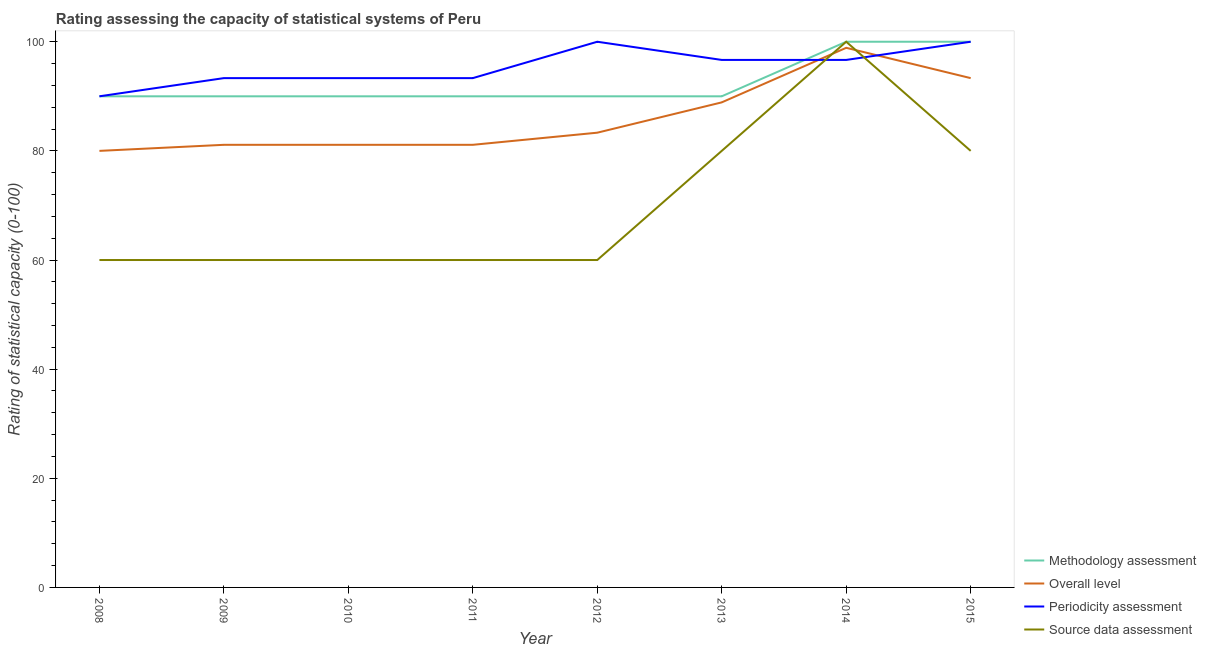Does the line corresponding to source data assessment rating intersect with the line corresponding to overall level rating?
Ensure brevity in your answer.  Yes. What is the methodology assessment rating in 2012?
Provide a succinct answer. 90. Across all years, what is the maximum overall level rating?
Your response must be concise. 98.89. Across all years, what is the minimum methodology assessment rating?
Your answer should be compact. 90. What is the total source data assessment rating in the graph?
Keep it short and to the point. 560. What is the difference between the overall level rating in 2013 and the source data assessment rating in 2008?
Your answer should be very brief. 28.89. What is the average methodology assessment rating per year?
Your answer should be compact. 92.5. In the year 2012, what is the difference between the source data assessment rating and methodology assessment rating?
Provide a succinct answer. -30. What is the ratio of the source data assessment rating in 2010 to that in 2012?
Give a very brief answer. 1. What is the difference between the highest and the second highest periodicity assessment rating?
Your answer should be compact. 0. What is the difference between the highest and the lowest overall level rating?
Keep it short and to the point. 18.89. In how many years, is the periodicity assessment rating greater than the average periodicity assessment rating taken over all years?
Your response must be concise. 4. Is the sum of the methodology assessment rating in 2011 and 2015 greater than the maximum periodicity assessment rating across all years?
Make the answer very short. Yes. Is it the case that in every year, the sum of the methodology assessment rating and periodicity assessment rating is greater than the sum of source data assessment rating and overall level rating?
Make the answer very short. Yes. Is it the case that in every year, the sum of the methodology assessment rating and overall level rating is greater than the periodicity assessment rating?
Provide a short and direct response. Yes. Is the periodicity assessment rating strictly less than the source data assessment rating over the years?
Ensure brevity in your answer.  No. What is the difference between two consecutive major ticks on the Y-axis?
Your answer should be compact. 20. How many legend labels are there?
Offer a very short reply. 4. How are the legend labels stacked?
Offer a very short reply. Vertical. What is the title of the graph?
Your answer should be very brief. Rating assessing the capacity of statistical systems of Peru. Does "Revenue mobilization" appear as one of the legend labels in the graph?
Offer a very short reply. No. What is the label or title of the Y-axis?
Your answer should be compact. Rating of statistical capacity (0-100). What is the Rating of statistical capacity (0-100) in Methodology assessment in 2008?
Ensure brevity in your answer.  90. What is the Rating of statistical capacity (0-100) of Source data assessment in 2008?
Offer a terse response. 60. What is the Rating of statistical capacity (0-100) in Methodology assessment in 2009?
Give a very brief answer. 90. What is the Rating of statistical capacity (0-100) of Overall level in 2009?
Provide a short and direct response. 81.11. What is the Rating of statistical capacity (0-100) of Periodicity assessment in 2009?
Your answer should be very brief. 93.33. What is the Rating of statistical capacity (0-100) of Source data assessment in 2009?
Your answer should be very brief. 60. What is the Rating of statistical capacity (0-100) of Methodology assessment in 2010?
Ensure brevity in your answer.  90. What is the Rating of statistical capacity (0-100) of Overall level in 2010?
Offer a very short reply. 81.11. What is the Rating of statistical capacity (0-100) of Periodicity assessment in 2010?
Your answer should be very brief. 93.33. What is the Rating of statistical capacity (0-100) of Source data assessment in 2010?
Make the answer very short. 60. What is the Rating of statistical capacity (0-100) in Overall level in 2011?
Provide a succinct answer. 81.11. What is the Rating of statistical capacity (0-100) of Periodicity assessment in 2011?
Keep it short and to the point. 93.33. What is the Rating of statistical capacity (0-100) of Source data assessment in 2011?
Your answer should be compact. 60. What is the Rating of statistical capacity (0-100) of Overall level in 2012?
Your answer should be compact. 83.33. What is the Rating of statistical capacity (0-100) of Periodicity assessment in 2012?
Your answer should be compact. 100. What is the Rating of statistical capacity (0-100) of Source data assessment in 2012?
Your response must be concise. 60. What is the Rating of statistical capacity (0-100) of Methodology assessment in 2013?
Keep it short and to the point. 90. What is the Rating of statistical capacity (0-100) in Overall level in 2013?
Your answer should be very brief. 88.89. What is the Rating of statistical capacity (0-100) in Periodicity assessment in 2013?
Ensure brevity in your answer.  96.67. What is the Rating of statistical capacity (0-100) in Source data assessment in 2013?
Provide a short and direct response. 80. What is the Rating of statistical capacity (0-100) of Methodology assessment in 2014?
Keep it short and to the point. 100. What is the Rating of statistical capacity (0-100) of Overall level in 2014?
Keep it short and to the point. 98.89. What is the Rating of statistical capacity (0-100) in Periodicity assessment in 2014?
Ensure brevity in your answer.  96.67. What is the Rating of statistical capacity (0-100) of Source data assessment in 2014?
Ensure brevity in your answer.  100. What is the Rating of statistical capacity (0-100) of Overall level in 2015?
Ensure brevity in your answer.  93.33. What is the Rating of statistical capacity (0-100) of Source data assessment in 2015?
Provide a succinct answer. 80. Across all years, what is the maximum Rating of statistical capacity (0-100) in Methodology assessment?
Make the answer very short. 100. Across all years, what is the maximum Rating of statistical capacity (0-100) in Overall level?
Offer a terse response. 98.89. Across all years, what is the minimum Rating of statistical capacity (0-100) in Methodology assessment?
Your response must be concise. 90. What is the total Rating of statistical capacity (0-100) of Methodology assessment in the graph?
Provide a succinct answer. 740. What is the total Rating of statistical capacity (0-100) in Overall level in the graph?
Your response must be concise. 687.78. What is the total Rating of statistical capacity (0-100) in Periodicity assessment in the graph?
Give a very brief answer. 763.33. What is the total Rating of statistical capacity (0-100) of Source data assessment in the graph?
Ensure brevity in your answer.  560. What is the difference between the Rating of statistical capacity (0-100) in Overall level in 2008 and that in 2009?
Offer a terse response. -1.11. What is the difference between the Rating of statistical capacity (0-100) in Source data assessment in 2008 and that in 2009?
Your answer should be compact. 0. What is the difference between the Rating of statistical capacity (0-100) of Overall level in 2008 and that in 2010?
Your answer should be very brief. -1.11. What is the difference between the Rating of statistical capacity (0-100) in Periodicity assessment in 2008 and that in 2010?
Provide a succinct answer. -3.33. What is the difference between the Rating of statistical capacity (0-100) in Methodology assessment in 2008 and that in 2011?
Make the answer very short. 0. What is the difference between the Rating of statistical capacity (0-100) of Overall level in 2008 and that in 2011?
Your answer should be very brief. -1.11. What is the difference between the Rating of statistical capacity (0-100) of Source data assessment in 2008 and that in 2011?
Give a very brief answer. 0. What is the difference between the Rating of statistical capacity (0-100) of Methodology assessment in 2008 and that in 2012?
Your response must be concise. 0. What is the difference between the Rating of statistical capacity (0-100) of Overall level in 2008 and that in 2012?
Give a very brief answer. -3.33. What is the difference between the Rating of statistical capacity (0-100) in Periodicity assessment in 2008 and that in 2012?
Your response must be concise. -10. What is the difference between the Rating of statistical capacity (0-100) of Source data assessment in 2008 and that in 2012?
Your answer should be compact. 0. What is the difference between the Rating of statistical capacity (0-100) in Methodology assessment in 2008 and that in 2013?
Keep it short and to the point. 0. What is the difference between the Rating of statistical capacity (0-100) of Overall level in 2008 and that in 2013?
Make the answer very short. -8.89. What is the difference between the Rating of statistical capacity (0-100) of Periodicity assessment in 2008 and that in 2013?
Your answer should be compact. -6.67. What is the difference between the Rating of statistical capacity (0-100) of Methodology assessment in 2008 and that in 2014?
Provide a succinct answer. -10. What is the difference between the Rating of statistical capacity (0-100) in Overall level in 2008 and that in 2014?
Offer a very short reply. -18.89. What is the difference between the Rating of statistical capacity (0-100) in Periodicity assessment in 2008 and that in 2014?
Give a very brief answer. -6.67. What is the difference between the Rating of statistical capacity (0-100) in Methodology assessment in 2008 and that in 2015?
Give a very brief answer. -10. What is the difference between the Rating of statistical capacity (0-100) in Overall level in 2008 and that in 2015?
Keep it short and to the point. -13.33. What is the difference between the Rating of statistical capacity (0-100) in Periodicity assessment in 2008 and that in 2015?
Make the answer very short. -10. What is the difference between the Rating of statistical capacity (0-100) in Methodology assessment in 2009 and that in 2010?
Keep it short and to the point. 0. What is the difference between the Rating of statistical capacity (0-100) in Overall level in 2009 and that in 2010?
Provide a short and direct response. 0. What is the difference between the Rating of statistical capacity (0-100) of Source data assessment in 2009 and that in 2010?
Keep it short and to the point. 0. What is the difference between the Rating of statistical capacity (0-100) in Overall level in 2009 and that in 2011?
Your response must be concise. 0. What is the difference between the Rating of statistical capacity (0-100) in Overall level in 2009 and that in 2012?
Make the answer very short. -2.22. What is the difference between the Rating of statistical capacity (0-100) of Periodicity assessment in 2009 and that in 2012?
Offer a very short reply. -6.67. What is the difference between the Rating of statistical capacity (0-100) of Overall level in 2009 and that in 2013?
Offer a very short reply. -7.78. What is the difference between the Rating of statistical capacity (0-100) of Source data assessment in 2009 and that in 2013?
Offer a very short reply. -20. What is the difference between the Rating of statistical capacity (0-100) of Methodology assessment in 2009 and that in 2014?
Your answer should be very brief. -10. What is the difference between the Rating of statistical capacity (0-100) of Overall level in 2009 and that in 2014?
Ensure brevity in your answer.  -17.78. What is the difference between the Rating of statistical capacity (0-100) in Overall level in 2009 and that in 2015?
Give a very brief answer. -12.22. What is the difference between the Rating of statistical capacity (0-100) in Periodicity assessment in 2009 and that in 2015?
Provide a short and direct response. -6.67. What is the difference between the Rating of statistical capacity (0-100) in Overall level in 2010 and that in 2011?
Give a very brief answer. 0. What is the difference between the Rating of statistical capacity (0-100) in Methodology assessment in 2010 and that in 2012?
Provide a short and direct response. 0. What is the difference between the Rating of statistical capacity (0-100) of Overall level in 2010 and that in 2012?
Make the answer very short. -2.22. What is the difference between the Rating of statistical capacity (0-100) of Periodicity assessment in 2010 and that in 2012?
Your answer should be very brief. -6.67. What is the difference between the Rating of statistical capacity (0-100) in Source data assessment in 2010 and that in 2012?
Your answer should be compact. 0. What is the difference between the Rating of statistical capacity (0-100) in Overall level in 2010 and that in 2013?
Offer a terse response. -7.78. What is the difference between the Rating of statistical capacity (0-100) in Overall level in 2010 and that in 2014?
Provide a short and direct response. -17.78. What is the difference between the Rating of statistical capacity (0-100) of Periodicity assessment in 2010 and that in 2014?
Your response must be concise. -3.33. What is the difference between the Rating of statistical capacity (0-100) in Methodology assessment in 2010 and that in 2015?
Your response must be concise. -10. What is the difference between the Rating of statistical capacity (0-100) in Overall level in 2010 and that in 2015?
Your answer should be compact. -12.22. What is the difference between the Rating of statistical capacity (0-100) in Periodicity assessment in 2010 and that in 2015?
Your answer should be very brief. -6.67. What is the difference between the Rating of statistical capacity (0-100) in Overall level in 2011 and that in 2012?
Ensure brevity in your answer.  -2.22. What is the difference between the Rating of statistical capacity (0-100) in Periodicity assessment in 2011 and that in 2012?
Your answer should be compact. -6.67. What is the difference between the Rating of statistical capacity (0-100) of Methodology assessment in 2011 and that in 2013?
Offer a terse response. 0. What is the difference between the Rating of statistical capacity (0-100) in Overall level in 2011 and that in 2013?
Your response must be concise. -7.78. What is the difference between the Rating of statistical capacity (0-100) of Source data assessment in 2011 and that in 2013?
Offer a terse response. -20. What is the difference between the Rating of statistical capacity (0-100) of Overall level in 2011 and that in 2014?
Make the answer very short. -17.78. What is the difference between the Rating of statistical capacity (0-100) in Periodicity assessment in 2011 and that in 2014?
Ensure brevity in your answer.  -3.33. What is the difference between the Rating of statistical capacity (0-100) in Overall level in 2011 and that in 2015?
Keep it short and to the point. -12.22. What is the difference between the Rating of statistical capacity (0-100) of Periodicity assessment in 2011 and that in 2015?
Make the answer very short. -6.67. What is the difference between the Rating of statistical capacity (0-100) of Overall level in 2012 and that in 2013?
Keep it short and to the point. -5.56. What is the difference between the Rating of statistical capacity (0-100) in Methodology assessment in 2012 and that in 2014?
Provide a short and direct response. -10. What is the difference between the Rating of statistical capacity (0-100) of Overall level in 2012 and that in 2014?
Your response must be concise. -15.56. What is the difference between the Rating of statistical capacity (0-100) in Periodicity assessment in 2012 and that in 2014?
Offer a terse response. 3.33. What is the difference between the Rating of statistical capacity (0-100) of Source data assessment in 2012 and that in 2014?
Give a very brief answer. -40. What is the difference between the Rating of statistical capacity (0-100) in Methodology assessment in 2012 and that in 2015?
Your answer should be compact. -10. What is the difference between the Rating of statistical capacity (0-100) in Source data assessment in 2012 and that in 2015?
Provide a succinct answer. -20. What is the difference between the Rating of statistical capacity (0-100) in Overall level in 2013 and that in 2014?
Keep it short and to the point. -10. What is the difference between the Rating of statistical capacity (0-100) in Source data assessment in 2013 and that in 2014?
Provide a short and direct response. -20. What is the difference between the Rating of statistical capacity (0-100) in Overall level in 2013 and that in 2015?
Give a very brief answer. -4.44. What is the difference between the Rating of statistical capacity (0-100) in Periodicity assessment in 2013 and that in 2015?
Offer a terse response. -3.33. What is the difference between the Rating of statistical capacity (0-100) of Overall level in 2014 and that in 2015?
Your answer should be very brief. 5.56. What is the difference between the Rating of statistical capacity (0-100) of Source data assessment in 2014 and that in 2015?
Your answer should be very brief. 20. What is the difference between the Rating of statistical capacity (0-100) in Methodology assessment in 2008 and the Rating of statistical capacity (0-100) in Overall level in 2009?
Your answer should be very brief. 8.89. What is the difference between the Rating of statistical capacity (0-100) in Methodology assessment in 2008 and the Rating of statistical capacity (0-100) in Periodicity assessment in 2009?
Ensure brevity in your answer.  -3.33. What is the difference between the Rating of statistical capacity (0-100) of Overall level in 2008 and the Rating of statistical capacity (0-100) of Periodicity assessment in 2009?
Ensure brevity in your answer.  -13.33. What is the difference between the Rating of statistical capacity (0-100) in Methodology assessment in 2008 and the Rating of statistical capacity (0-100) in Overall level in 2010?
Offer a very short reply. 8.89. What is the difference between the Rating of statistical capacity (0-100) of Methodology assessment in 2008 and the Rating of statistical capacity (0-100) of Periodicity assessment in 2010?
Make the answer very short. -3.33. What is the difference between the Rating of statistical capacity (0-100) of Methodology assessment in 2008 and the Rating of statistical capacity (0-100) of Source data assessment in 2010?
Offer a terse response. 30. What is the difference between the Rating of statistical capacity (0-100) in Overall level in 2008 and the Rating of statistical capacity (0-100) in Periodicity assessment in 2010?
Your answer should be compact. -13.33. What is the difference between the Rating of statistical capacity (0-100) of Methodology assessment in 2008 and the Rating of statistical capacity (0-100) of Overall level in 2011?
Offer a terse response. 8.89. What is the difference between the Rating of statistical capacity (0-100) of Overall level in 2008 and the Rating of statistical capacity (0-100) of Periodicity assessment in 2011?
Keep it short and to the point. -13.33. What is the difference between the Rating of statistical capacity (0-100) of Overall level in 2008 and the Rating of statistical capacity (0-100) of Source data assessment in 2011?
Provide a succinct answer. 20. What is the difference between the Rating of statistical capacity (0-100) of Periodicity assessment in 2008 and the Rating of statistical capacity (0-100) of Source data assessment in 2011?
Ensure brevity in your answer.  30. What is the difference between the Rating of statistical capacity (0-100) in Methodology assessment in 2008 and the Rating of statistical capacity (0-100) in Overall level in 2012?
Keep it short and to the point. 6.67. What is the difference between the Rating of statistical capacity (0-100) of Methodology assessment in 2008 and the Rating of statistical capacity (0-100) of Periodicity assessment in 2012?
Offer a terse response. -10. What is the difference between the Rating of statistical capacity (0-100) of Methodology assessment in 2008 and the Rating of statistical capacity (0-100) of Source data assessment in 2012?
Make the answer very short. 30. What is the difference between the Rating of statistical capacity (0-100) of Overall level in 2008 and the Rating of statistical capacity (0-100) of Source data assessment in 2012?
Provide a short and direct response. 20. What is the difference between the Rating of statistical capacity (0-100) in Methodology assessment in 2008 and the Rating of statistical capacity (0-100) in Overall level in 2013?
Offer a very short reply. 1.11. What is the difference between the Rating of statistical capacity (0-100) in Methodology assessment in 2008 and the Rating of statistical capacity (0-100) in Periodicity assessment in 2013?
Provide a short and direct response. -6.67. What is the difference between the Rating of statistical capacity (0-100) of Overall level in 2008 and the Rating of statistical capacity (0-100) of Periodicity assessment in 2013?
Make the answer very short. -16.67. What is the difference between the Rating of statistical capacity (0-100) of Methodology assessment in 2008 and the Rating of statistical capacity (0-100) of Overall level in 2014?
Your answer should be very brief. -8.89. What is the difference between the Rating of statistical capacity (0-100) of Methodology assessment in 2008 and the Rating of statistical capacity (0-100) of Periodicity assessment in 2014?
Your response must be concise. -6.67. What is the difference between the Rating of statistical capacity (0-100) in Methodology assessment in 2008 and the Rating of statistical capacity (0-100) in Source data assessment in 2014?
Give a very brief answer. -10. What is the difference between the Rating of statistical capacity (0-100) of Overall level in 2008 and the Rating of statistical capacity (0-100) of Periodicity assessment in 2014?
Make the answer very short. -16.67. What is the difference between the Rating of statistical capacity (0-100) in Overall level in 2008 and the Rating of statistical capacity (0-100) in Source data assessment in 2014?
Offer a terse response. -20. What is the difference between the Rating of statistical capacity (0-100) in Methodology assessment in 2008 and the Rating of statistical capacity (0-100) in Overall level in 2015?
Provide a succinct answer. -3.33. What is the difference between the Rating of statistical capacity (0-100) in Methodology assessment in 2008 and the Rating of statistical capacity (0-100) in Periodicity assessment in 2015?
Make the answer very short. -10. What is the difference between the Rating of statistical capacity (0-100) in Overall level in 2008 and the Rating of statistical capacity (0-100) in Periodicity assessment in 2015?
Your response must be concise. -20. What is the difference between the Rating of statistical capacity (0-100) of Overall level in 2008 and the Rating of statistical capacity (0-100) of Source data assessment in 2015?
Offer a terse response. 0. What is the difference between the Rating of statistical capacity (0-100) of Methodology assessment in 2009 and the Rating of statistical capacity (0-100) of Overall level in 2010?
Offer a very short reply. 8.89. What is the difference between the Rating of statistical capacity (0-100) of Methodology assessment in 2009 and the Rating of statistical capacity (0-100) of Periodicity assessment in 2010?
Your response must be concise. -3.33. What is the difference between the Rating of statistical capacity (0-100) in Overall level in 2009 and the Rating of statistical capacity (0-100) in Periodicity assessment in 2010?
Give a very brief answer. -12.22. What is the difference between the Rating of statistical capacity (0-100) of Overall level in 2009 and the Rating of statistical capacity (0-100) of Source data assessment in 2010?
Your answer should be compact. 21.11. What is the difference between the Rating of statistical capacity (0-100) in Periodicity assessment in 2009 and the Rating of statistical capacity (0-100) in Source data assessment in 2010?
Ensure brevity in your answer.  33.33. What is the difference between the Rating of statistical capacity (0-100) of Methodology assessment in 2009 and the Rating of statistical capacity (0-100) of Overall level in 2011?
Your response must be concise. 8.89. What is the difference between the Rating of statistical capacity (0-100) in Methodology assessment in 2009 and the Rating of statistical capacity (0-100) in Periodicity assessment in 2011?
Your response must be concise. -3.33. What is the difference between the Rating of statistical capacity (0-100) in Overall level in 2009 and the Rating of statistical capacity (0-100) in Periodicity assessment in 2011?
Make the answer very short. -12.22. What is the difference between the Rating of statistical capacity (0-100) in Overall level in 2009 and the Rating of statistical capacity (0-100) in Source data assessment in 2011?
Offer a terse response. 21.11. What is the difference between the Rating of statistical capacity (0-100) in Periodicity assessment in 2009 and the Rating of statistical capacity (0-100) in Source data assessment in 2011?
Keep it short and to the point. 33.33. What is the difference between the Rating of statistical capacity (0-100) of Methodology assessment in 2009 and the Rating of statistical capacity (0-100) of Periodicity assessment in 2012?
Your answer should be very brief. -10. What is the difference between the Rating of statistical capacity (0-100) in Overall level in 2009 and the Rating of statistical capacity (0-100) in Periodicity assessment in 2012?
Your response must be concise. -18.89. What is the difference between the Rating of statistical capacity (0-100) of Overall level in 2009 and the Rating of statistical capacity (0-100) of Source data assessment in 2012?
Your response must be concise. 21.11. What is the difference between the Rating of statistical capacity (0-100) of Periodicity assessment in 2009 and the Rating of statistical capacity (0-100) of Source data assessment in 2012?
Give a very brief answer. 33.33. What is the difference between the Rating of statistical capacity (0-100) in Methodology assessment in 2009 and the Rating of statistical capacity (0-100) in Overall level in 2013?
Give a very brief answer. 1.11. What is the difference between the Rating of statistical capacity (0-100) of Methodology assessment in 2009 and the Rating of statistical capacity (0-100) of Periodicity assessment in 2013?
Provide a short and direct response. -6.67. What is the difference between the Rating of statistical capacity (0-100) in Methodology assessment in 2009 and the Rating of statistical capacity (0-100) in Source data assessment in 2013?
Make the answer very short. 10. What is the difference between the Rating of statistical capacity (0-100) of Overall level in 2009 and the Rating of statistical capacity (0-100) of Periodicity assessment in 2013?
Your response must be concise. -15.56. What is the difference between the Rating of statistical capacity (0-100) in Periodicity assessment in 2009 and the Rating of statistical capacity (0-100) in Source data assessment in 2013?
Give a very brief answer. 13.33. What is the difference between the Rating of statistical capacity (0-100) of Methodology assessment in 2009 and the Rating of statistical capacity (0-100) of Overall level in 2014?
Give a very brief answer. -8.89. What is the difference between the Rating of statistical capacity (0-100) in Methodology assessment in 2009 and the Rating of statistical capacity (0-100) in Periodicity assessment in 2014?
Offer a very short reply. -6.67. What is the difference between the Rating of statistical capacity (0-100) in Methodology assessment in 2009 and the Rating of statistical capacity (0-100) in Source data assessment in 2014?
Provide a succinct answer. -10. What is the difference between the Rating of statistical capacity (0-100) in Overall level in 2009 and the Rating of statistical capacity (0-100) in Periodicity assessment in 2014?
Your answer should be compact. -15.56. What is the difference between the Rating of statistical capacity (0-100) in Overall level in 2009 and the Rating of statistical capacity (0-100) in Source data assessment in 2014?
Provide a succinct answer. -18.89. What is the difference between the Rating of statistical capacity (0-100) of Periodicity assessment in 2009 and the Rating of statistical capacity (0-100) of Source data assessment in 2014?
Provide a succinct answer. -6.67. What is the difference between the Rating of statistical capacity (0-100) in Overall level in 2009 and the Rating of statistical capacity (0-100) in Periodicity assessment in 2015?
Your answer should be compact. -18.89. What is the difference between the Rating of statistical capacity (0-100) of Periodicity assessment in 2009 and the Rating of statistical capacity (0-100) of Source data assessment in 2015?
Your answer should be compact. 13.33. What is the difference between the Rating of statistical capacity (0-100) in Methodology assessment in 2010 and the Rating of statistical capacity (0-100) in Overall level in 2011?
Offer a terse response. 8.89. What is the difference between the Rating of statistical capacity (0-100) of Overall level in 2010 and the Rating of statistical capacity (0-100) of Periodicity assessment in 2011?
Keep it short and to the point. -12.22. What is the difference between the Rating of statistical capacity (0-100) of Overall level in 2010 and the Rating of statistical capacity (0-100) of Source data assessment in 2011?
Your answer should be very brief. 21.11. What is the difference between the Rating of statistical capacity (0-100) of Periodicity assessment in 2010 and the Rating of statistical capacity (0-100) of Source data assessment in 2011?
Ensure brevity in your answer.  33.33. What is the difference between the Rating of statistical capacity (0-100) in Methodology assessment in 2010 and the Rating of statistical capacity (0-100) in Overall level in 2012?
Keep it short and to the point. 6.67. What is the difference between the Rating of statistical capacity (0-100) in Methodology assessment in 2010 and the Rating of statistical capacity (0-100) in Periodicity assessment in 2012?
Provide a succinct answer. -10. What is the difference between the Rating of statistical capacity (0-100) in Methodology assessment in 2010 and the Rating of statistical capacity (0-100) in Source data assessment in 2012?
Your answer should be very brief. 30. What is the difference between the Rating of statistical capacity (0-100) of Overall level in 2010 and the Rating of statistical capacity (0-100) of Periodicity assessment in 2012?
Keep it short and to the point. -18.89. What is the difference between the Rating of statistical capacity (0-100) of Overall level in 2010 and the Rating of statistical capacity (0-100) of Source data assessment in 2012?
Your answer should be compact. 21.11. What is the difference between the Rating of statistical capacity (0-100) in Periodicity assessment in 2010 and the Rating of statistical capacity (0-100) in Source data assessment in 2012?
Keep it short and to the point. 33.33. What is the difference between the Rating of statistical capacity (0-100) in Methodology assessment in 2010 and the Rating of statistical capacity (0-100) in Overall level in 2013?
Your answer should be very brief. 1.11. What is the difference between the Rating of statistical capacity (0-100) in Methodology assessment in 2010 and the Rating of statistical capacity (0-100) in Periodicity assessment in 2013?
Keep it short and to the point. -6.67. What is the difference between the Rating of statistical capacity (0-100) in Overall level in 2010 and the Rating of statistical capacity (0-100) in Periodicity assessment in 2013?
Provide a short and direct response. -15.56. What is the difference between the Rating of statistical capacity (0-100) of Periodicity assessment in 2010 and the Rating of statistical capacity (0-100) of Source data assessment in 2013?
Provide a short and direct response. 13.33. What is the difference between the Rating of statistical capacity (0-100) in Methodology assessment in 2010 and the Rating of statistical capacity (0-100) in Overall level in 2014?
Offer a terse response. -8.89. What is the difference between the Rating of statistical capacity (0-100) of Methodology assessment in 2010 and the Rating of statistical capacity (0-100) of Periodicity assessment in 2014?
Provide a short and direct response. -6.67. What is the difference between the Rating of statistical capacity (0-100) of Methodology assessment in 2010 and the Rating of statistical capacity (0-100) of Source data assessment in 2014?
Give a very brief answer. -10. What is the difference between the Rating of statistical capacity (0-100) in Overall level in 2010 and the Rating of statistical capacity (0-100) in Periodicity assessment in 2014?
Give a very brief answer. -15.56. What is the difference between the Rating of statistical capacity (0-100) of Overall level in 2010 and the Rating of statistical capacity (0-100) of Source data assessment in 2014?
Ensure brevity in your answer.  -18.89. What is the difference between the Rating of statistical capacity (0-100) of Periodicity assessment in 2010 and the Rating of statistical capacity (0-100) of Source data assessment in 2014?
Ensure brevity in your answer.  -6.67. What is the difference between the Rating of statistical capacity (0-100) in Methodology assessment in 2010 and the Rating of statistical capacity (0-100) in Overall level in 2015?
Your response must be concise. -3.33. What is the difference between the Rating of statistical capacity (0-100) of Methodology assessment in 2010 and the Rating of statistical capacity (0-100) of Periodicity assessment in 2015?
Your answer should be very brief. -10. What is the difference between the Rating of statistical capacity (0-100) of Overall level in 2010 and the Rating of statistical capacity (0-100) of Periodicity assessment in 2015?
Ensure brevity in your answer.  -18.89. What is the difference between the Rating of statistical capacity (0-100) of Periodicity assessment in 2010 and the Rating of statistical capacity (0-100) of Source data assessment in 2015?
Your response must be concise. 13.33. What is the difference between the Rating of statistical capacity (0-100) in Methodology assessment in 2011 and the Rating of statistical capacity (0-100) in Overall level in 2012?
Offer a terse response. 6.67. What is the difference between the Rating of statistical capacity (0-100) in Methodology assessment in 2011 and the Rating of statistical capacity (0-100) in Source data assessment in 2012?
Keep it short and to the point. 30. What is the difference between the Rating of statistical capacity (0-100) of Overall level in 2011 and the Rating of statistical capacity (0-100) of Periodicity assessment in 2012?
Make the answer very short. -18.89. What is the difference between the Rating of statistical capacity (0-100) in Overall level in 2011 and the Rating of statistical capacity (0-100) in Source data assessment in 2012?
Offer a very short reply. 21.11. What is the difference between the Rating of statistical capacity (0-100) of Periodicity assessment in 2011 and the Rating of statistical capacity (0-100) of Source data assessment in 2012?
Keep it short and to the point. 33.33. What is the difference between the Rating of statistical capacity (0-100) of Methodology assessment in 2011 and the Rating of statistical capacity (0-100) of Overall level in 2013?
Keep it short and to the point. 1.11. What is the difference between the Rating of statistical capacity (0-100) of Methodology assessment in 2011 and the Rating of statistical capacity (0-100) of Periodicity assessment in 2013?
Your response must be concise. -6.67. What is the difference between the Rating of statistical capacity (0-100) in Methodology assessment in 2011 and the Rating of statistical capacity (0-100) in Source data assessment in 2013?
Your response must be concise. 10. What is the difference between the Rating of statistical capacity (0-100) of Overall level in 2011 and the Rating of statistical capacity (0-100) of Periodicity assessment in 2013?
Keep it short and to the point. -15.56. What is the difference between the Rating of statistical capacity (0-100) of Overall level in 2011 and the Rating of statistical capacity (0-100) of Source data assessment in 2013?
Your answer should be compact. 1.11. What is the difference between the Rating of statistical capacity (0-100) of Periodicity assessment in 2011 and the Rating of statistical capacity (0-100) of Source data assessment in 2013?
Your response must be concise. 13.33. What is the difference between the Rating of statistical capacity (0-100) of Methodology assessment in 2011 and the Rating of statistical capacity (0-100) of Overall level in 2014?
Keep it short and to the point. -8.89. What is the difference between the Rating of statistical capacity (0-100) in Methodology assessment in 2011 and the Rating of statistical capacity (0-100) in Periodicity assessment in 2014?
Provide a succinct answer. -6.67. What is the difference between the Rating of statistical capacity (0-100) in Overall level in 2011 and the Rating of statistical capacity (0-100) in Periodicity assessment in 2014?
Ensure brevity in your answer.  -15.56. What is the difference between the Rating of statistical capacity (0-100) in Overall level in 2011 and the Rating of statistical capacity (0-100) in Source data assessment in 2014?
Your answer should be compact. -18.89. What is the difference between the Rating of statistical capacity (0-100) of Periodicity assessment in 2011 and the Rating of statistical capacity (0-100) of Source data assessment in 2014?
Your answer should be very brief. -6.67. What is the difference between the Rating of statistical capacity (0-100) of Methodology assessment in 2011 and the Rating of statistical capacity (0-100) of Overall level in 2015?
Your answer should be compact. -3.33. What is the difference between the Rating of statistical capacity (0-100) in Overall level in 2011 and the Rating of statistical capacity (0-100) in Periodicity assessment in 2015?
Ensure brevity in your answer.  -18.89. What is the difference between the Rating of statistical capacity (0-100) in Periodicity assessment in 2011 and the Rating of statistical capacity (0-100) in Source data assessment in 2015?
Keep it short and to the point. 13.33. What is the difference between the Rating of statistical capacity (0-100) of Methodology assessment in 2012 and the Rating of statistical capacity (0-100) of Overall level in 2013?
Your answer should be compact. 1.11. What is the difference between the Rating of statistical capacity (0-100) of Methodology assessment in 2012 and the Rating of statistical capacity (0-100) of Periodicity assessment in 2013?
Give a very brief answer. -6.67. What is the difference between the Rating of statistical capacity (0-100) in Overall level in 2012 and the Rating of statistical capacity (0-100) in Periodicity assessment in 2013?
Your answer should be very brief. -13.33. What is the difference between the Rating of statistical capacity (0-100) of Overall level in 2012 and the Rating of statistical capacity (0-100) of Source data assessment in 2013?
Your answer should be compact. 3.33. What is the difference between the Rating of statistical capacity (0-100) of Methodology assessment in 2012 and the Rating of statistical capacity (0-100) of Overall level in 2014?
Offer a very short reply. -8.89. What is the difference between the Rating of statistical capacity (0-100) of Methodology assessment in 2012 and the Rating of statistical capacity (0-100) of Periodicity assessment in 2014?
Your response must be concise. -6.67. What is the difference between the Rating of statistical capacity (0-100) of Overall level in 2012 and the Rating of statistical capacity (0-100) of Periodicity assessment in 2014?
Give a very brief answer. -13.33. What is the difference between the Rating of statistical capacity (0-100) in Overall level in 2012 and the Rating of statistical capacity (0-100) in Source data assessment in 2014?
Make the answer very short. -16.67. What is the difference between the Rating of statistical capacity (0-100) of Periodicity assessment in 2012 and the Rating of statistical capacity (0-100) of Source data assessment in 2014?
Provide a succinct answer. 0. What is the difference between the Rating of statistical capacity (0-100) in Methodology assessment in 2012 and the Rating of statistical capacity (0-100) in Overall level in 2015?
Your response must be concise. -3.33. What is the difference between the Rating of statistical capacity (0-100) in Methodology assessment in 2012 and the Rating of statistical capacity (0-100) in Periodicity assessment in 2015?
Keep it short and to the point. -10. What is the difference between the Rating of statistical capacity (0-100) of Overall level in 2012 and the Rating of statistical capacity (0-100) of Periodicity assessment in 2015?
Offer a terse response. -16.67. What is the difference between the Rating of statistical capacity (0-100) in Methodology assessment in 2013 and the Rating of statistical capacity (0-100) in Overall level in 2014?
Offer a terse response. -8.89. What is the difference between the Rating of statistical capacity (0-100) in Methodology assessment in 2013 and the Rating of statistical capacity (0-100) in Periodicity assessment in 2014?
Give a very brief answer. -6.67. What is the difference between the Rating of statistical capacity (0-100) of Overall level in 2013 and the Rating of statistical capacity (0-100) of Periodicity assessment in 2014?
Make the answer very short. -7.78. What is the difference between the Rating of statistical capacity (0-100) of Overall level in 2013 and the Rating of statistical capacity (0-100) of Source data assessment in 2014?
Provide a short and direct response. -11.11. What is the difference between the Rating of statistical capacity (0-100) of Methodology assessment in 2013 and the Rating of statistical capacity (0-100) of Overall level in 2015?
Offer a terse response. -3.33. What is the difference between the Rating of statistical capacity (0-100) in Methodology assessment in 2013 and the Rating of statistical capacity (0-100) in Source data assessment in 2015?
Offer a very short reply. 10. What is the difference between the Rating of statistical capacity (0-100) of Overall level in 2013 and the Rating of statistical capacity (0-100) of Periodicity assessment in 2015?
Provide a succinct answer. -11.11. What is the difference between the Rating of statistical capacity (0-100) in Overall level in 2013 and the Rating of statistical capacity (0-100) in Source data assessment in 2015?
Ensure brevity in your answer.  8.89. What is the difference between the Rating of statistical capacity (0-100) of Periodicity assessment in 2013 and the Rating of statistical capacity (0-100) of Source data assessment in 2015?
Offer a very short reply. 16.67. What is the difference between the Rating of statistical capacity (0-100) in Methodology assessment in 2014 and the Rating of statistical capacity (0-100) in Overall level in 2015?
Ensure brevity in your answer.  6.67. What is the difference between the Rating of statistical capacity (0-100) in Methodology assessment in 2014 and the Rating of statistical capacity (0-100) in Periodicity assessment in 2015?
Make the answer very short. 0. What is the difference between the Rating of statistical capacity (0-100) in Overall level in 2014 and the Rating of statistical capacity (0-100) in Periodicity assessment in 2015?
Provide a succinct answer. -1.11. What is the difference between the Rating of statistical capacity (0-100) of Overall level in 2014 and the Rating of statistical capacity (0-100) of Source data assessment in 2015?
Your answer should be compact. 18.89. What is the difference between the Rating of statistical capacity (0-100) of Periodicity assessment in 2014 and the Rating of statistical capacity (0-100) of Source data assessment in 2015?
Keep it short and to the point. 16.67. What is the average Rating of statistical capacity (0-100) in Methodology assessment per year?
Ensure brevity in your answer.  92.5. What is the average Rating of statistical capacity (0-100) of Overall level per year?
Give a very brief answer. 85.97. What is the average Rating of statistical capacity (0-100) in Periodicity assessment per year?
Make the answer very short. 95.42. In the year 2008, what is the difference between the Rating of statistical capacity (0-100) of Methodology assessment and Rating of statistical capacity (0-100) of Overall level?
Provide a short and direct response. 10. In the year 2008, what is the difference between the Rating of statistical capacity (0-100) in Methodology assessment and Rating of statistical capacity (0-100) in Source data assessment?
Your response must be concise. 30. In the year 2008, what is the difference between the Rating of statistical capacity (0-100) in Overall level and Rating of statistical capacity (0-100) in Periodicity assessment?
Provide a short and direct response. -10. In the year 2009, what is the difference between the Rating of statistical capacity (0-100) in Methodology assessment and Rating of statistical capacity (0-100) in Overall level?
Your answer should be compact. 8.89. In the year 2009, what is the difference between the Rating of statistical capacity (0-100) in Overall level and Rating of statistical capacity (0-100) in Periodicity assessment?
Provide a succinct answer. -12.22. In the year 2009, what is the difference between the Rating of statistical capacity (0-100) in Overall level and Rating of statistical capacity (0-100) in Source data assessment?
Offer a very short reply. 21.11. In the year 2009, what is the difference between the Rating of statistical capacity (0-100) in Periodicity assessment and Rating of statistical capacity (0-100) in Source data assessment?
Ensure brevity in your answer.  33.33. In the year 2010, what is the difference between the Rating of statistical capacity (0-100) in Methodology assessment and Rating of statistical capacity (0-100) in Overall level?
Provide a succinct answer. 8.89. In the year 2010, what is the difference between the Rating of statistical capacity (0-100) of Methodology assessment and Rating of statistical capacity (0-100) of Periodicity assessment?
Offer a terse response. -3.33. In the year 2010, what is the difference between the Rating of statistical capacity (0-100) in Overall level and Rating of statistical capacity (0-100) in Periodicity assessment?
Offer a very short reply. -12.22. In the year 2010, what is the difference between the Rating of statistical capacity (0-100) in Overall level and Rating of statistical capacity (0-100) in Source data assessment?
Make the answer very short. 21.11. In the year 2010, what is the difference between the Rating of statistical capacity (0-100) in Periodicity assessment and Rating of statistical capacity (0-100) in Source data assessment?
Provide a short and direct response. 33.33. In the year 2011, what is the difference between the Rating of statistical capacity (0-100) in Methodology assessment and Rating of statistical capacity (0-100) in Overall level?
Your answer should be very brief. 8.89. In the year 2011, what is the difference between the Rating of statistical capacity (0-100) of Methodology assessment and Rating of statistical capacity (0-100) of Source data assessment?
Ensure brevity in your answer.  30. In the year 2011, what is the difference between the Rating of statistical capacity (0-100) of Overall level and Rating of statistical capacity (0-100) of Periodicity assessment?
Your response must be concise. -12.22. In the year 2011, what is the difference between the Rating of statistical capacity (0-100) of Overall level and Rating of statistical capacity (0-100) of Source data assessment?
Your response must be concise. 21.11. In the year 2011, what is the difference between the Rating of statistical capacity (0-100) of Periodicity assessment and Rating of statistical capacity (0-100) of Source data assessment?
Give a very brief answer. 33.33. In the year 2012, what is the difference between the Rating of statistical capacity (0-100) in Methodology assessment and Rating of statistical capacity (0-100) in Overall level?
Offer a very short reply. 6.67. In the year 2012, what is the difference between the Rating of statistical capacity (0-100) in Methodology assessment and Rating of statistical capacity (0-100) in Source data assessment?
Ensure brevity in your answer.  30. In the year 2012, what is the difference between the Rating of statistical capacity (0-100) of Overall level and Rating of statistical capacity (0-100) of Periodicity assessment?
Give a very brief answer. -16.67. In the year 2012, what is the difference between the Rating of statistical capacity (0-100) in Overall level and Rating of statistical capacity (0-100) in Source data assessment?
Provide a succinct answer. 23.33. In the year 2012, what is the difference between the Rating of statistical capacity (0-100) of Periodicity assessment and Rating of statistical capacity (0-100) of Source data assessment?
Provide a succinct answer. 40. In the year 2013, what is the difference between the Rating of statistical capacity (0-100) in Methodology assessment and Rating of statistical capacity (0-100) in Overall level?
Provide a succinct answer. 1.11. In the year 2013, what is the difference between the Rating of statistical capacity (0-100) in Methodology assessment and Rating of statistical capacity (0-100) in Periodicity assessment?
Provide a short and direct response. -6.67. In the year 2013, what is the difference between the Rating of statistical capacity (0-100) in Methodology assessment and Rating of statistical capacity (0-100) in Source data assessment?
Offer a terse response. 10. In the year 2013, what is the difference between the Rating of statistical capacity (0-100) in Overall level and Rating of statistical capacity (0-100) in Periodicity assessment?
Offer a very short reply. -7.78. In the year 2013, what is the difference between the Rating of statistical capacity (0-100) of Overall level and Rating of statistical capacity (0-100) of Source data assessment?
Offer a terse response. 8.89. In the year 2013, what is the difference between the Rating of statistical capacity (0-100) of Periodicity assessment and Rating of statistical capacity (0-100) of Source data assessment?
Offer a very short reply. 16.67. In the year 2014, what is the difference between the Rating of statistical capacity (0-100) of Methodology assessment and Rating of statistical capacity (0-100) of Periodicity assessment?
Ensure brevity in your answer.  3.33. In the year 2014, what is the difference between the Rating of statistical capacity (0-100) of Methodology assessment and Rating of statistical capacity (0-100) of Source data assessment?
Make the answer very short. 0. In the year 2014, what is the difference between the Rating of statistical capacity (0-100) in Overall level and Rating of statistical capacity (0-100) in Periodicity assessment?
Offer a terse response. 2.22. In the year 2014, what is the difference between the Rating of statistical capacity (0-100) of Overall level and Rating of statistical capacity (0-100) of Source data assessment?
Provide a succinct answer. -1.11. In the year 2014, what is the difference between the Rating of statistical capacity (0-100) in Periodicity assessment and Rating of statistical capacity (0-100) in Source data assessment?
Your answer should be very brief. -3.33. In the year 2015, what is the difference between the Rating of statistical capacity (0-100) of Methodology assessment and Rating of statistical capacity (0-100) of Source data assessment?
Make the answer very short. 20. In the year 2015, what is the difference between the Rating of statistical capacity (0-100) of Overall level and Rating of statistical capacity (0-100) of Periodicity assessment?
Your answer should be very brief. -6.67. In the year 2015, what is the difference between the Rating of statistical capacity (0-100) in Overall level and Rating of statistical capacity (0-100) in Source data assessment?
Your answer should be very brief. 13.33. What is the ratio of the Rating of statistical capacity (0-100) of Overall level in 2008 to that in 2009?
Make the answer very short. 0.99. What is the ratio of the Rating of statistical capacity (0-100) of Periodicity assessment in 2008 to that in 2009?
Provide a succinct answer. 0.96. What is the ratio of the Rating of statistical capacity (0-100) in Overall level in 2008 to that in 2010?
Provide a succinct answer. 0.99. What is the ratio of the Rating of statistical capacity (0-100) of Periodicity assessment in 2008 to that in 2010?
Offer a terse response. 0.96. What is the ratio of the Rating of statistical capacity (0-100) in Source data assessment in 2008 to that in 2010?
Provide a short and direct response. 1. What is the ratio of the Rating of statistical capacity (0-100) in Overall level in 2008 to that in 2011?
Offer a very short reply. 0.99. What is the ratio of the Rating of statistical capacity (0-100) in Source data assessment in 2008 to that in 2011?
Provide a succinct answer. 1. What is the ratio of the Rating of statistical capacity (0-100) in Methodology assessment in 2008 to that in 2012?
Ensure brevity in your answer.  1. What is the ratio of the Rating of statistical capacity (0-100) of Periodicity assessment in 2008 to that in 2012?
Provide a succinct answer. 0.9. What is the ratio of the Rating of statistical capacity (0-100) of Source data assessment in 2008 to that in 2012?
Provide a short and direct response. 1. What is the ratio of the Rating of statistical capacity (0-100) of Overall level in 2008 to that in 2013?
Offer a terse response. 0.9. What is the ratio of the Rating of statistical capacity (0-100) in Periodicity assessment in 2008 to that in 2013?
Your answer should be compact. 0.93. What is the ratio of the Rating of statistical capacity (0-100) of Overall level in 2008 to that in 2014?
Keep it short and to the point. 0.81. What is the ratio of the Rating of statistical capacity (0-100) of Periodicity assessment in 2008 to that in 2014?
Your response must be concise. 0.93. What is the ratio of the Rating of statistical capacity (0-100) in Source data assessment in 2008 to that in 2014?
Ensure brevity in your answer.  0.6. What is the ratio of the Rating of statistical capacity (0-100) in Overall level in 2008 to that in 2015?
Offer a very short reply. 0.86. What is the ratio of the Rating of statistical capacity (0-100) of Periodicity assessment in 2008 to that in 2015?
Your answer should be very brief. 0.9. What is the ratio of the Rating of statistical capacity (0-100) in Source data assessment in 2008 to that in 2015?
Keep it short and to the point. 0.75. What is the ratio of the Rating of statistical capacity (0-100) of Methodology assessment in 2009 to that in 2010?
Your answer should be compact. 1. What is the ratio of the Rating of statistical capacity (0-100) of Overall level in 2009 to that in 2010?
Provide a short and direct response. 1. What is the ratio of the Rating of statistical capacity (0-100) of Periodicity assessment in 2009 to that in 2010?
Your answer should be very brief. 1. What is the ratio of the Rating of statistical capacity (0-100) of Methodology assessment in 2009 to that in 2011?
Ensure brevity in your answer.  1. What is the ratio of the Rating of statistical capacity (0-100) of Overall level in 2009 to that in 2011?
Provide a short and direct response. 1. What is the ratio of the Rating of statistical capacity (0-100) in Periodicity assessment in 2009 to that in 2011?
Make the answer very short. 1. What is the ratio of the Rating of statistical capacity (0-100) of Source data assessment in 2009 to that in 2011?
Make the answer very short. 1. What is the ratio of the Rating of statistical capacity (0-100) of Overall level in 2009 to that in 2012?
Offer a terse response. 0.97. What is the ratio of the Rating of statistical capacity (0-100) in Source data assessment in 2009 to that in 2012?
Your response must be concise. 1. What is the ratio of the Rating of statistical capacity (0-100) of Overall level in 2009 to that in 2013?
Provide a short and direct response. 0.91. What is the ratio of the Rating of statistical capacity (0-100) of Periodicity assessment in 2009 to that in 2013?
Keep it short and to the point. 0.97. What is the ratio of the Rating of statistical capacity (0-100) of Source data assessment in 2009 to that in 2013?
Your answer should be very brief. 0.75. What is the ratio of the Rating of statistical capacity (0-100) in Overall level in 2009 to that in 2014?
Provide a succinct answer. 0.82. What is the ratio of the Rating of statistical capacity (0-100) in Periodicity assessment in 2009 to that in 2014?
Give a very brief answer. 0.97. What is the ratio of the Rating of statistical capacity (0-100) in Overall level in 2009 to that in 2015?
Make the answer very short. 0.87. What is the ratio of the Rating of statistical capacity (0-100) in Source data assessment in 2009 to that in 2015?
Provide a short and direct response. 0.75. What is the ratio of the Rating of statistical capacity (0-100) of Methodology assessment in 2010 to that in 2011?
Your response must be concise. 1. What is the ratio of the Rating of statistical capacity (0-100) in Overall level in 2010 to that in 2011?
Provide a short and direct response. 1. What is the ratio of the Rating of statistical capacity (0-100) in Periodicity assessment in 2010 to that in 2011?
Offer a very short reply. 1. What is the ratio of the Rating of statistical capacity (0-100) of Source data assessment in 2010 to that in 2011?
Your answer should be very brief. 1. What is the ratio of the Rating of statistical capacity (0-100) of Methodology assessment in 2010 to that in 2012?
Your answer should be compact. 1. What is the ratio of the Rating of statistical capacity (0-100) in Overall level in 2010 to that in 2012?
Offer a very short reply. 0.97. What is the ratio of the Rating of statistical capacity (0-100) of Methodology assessment in 2010 to that in 2013?
Make the answer very short. 1. What is the ratio of the Rating of statistical capacity (0-100) of Overall level in 2010 to that in 2013?
Offer a terse response. 0.91. What is the ratio of the Rating of statistical capacity (0-100) of Periodicity assessment in 2010 to that in 2013?
Keep it short and to the point. 0.97. What is the ratio of the Rating of statistical capacity (0-100) of Source data assessment in 2010 to that in 2013?
Ensure brevity in your answer.  0.75. What is the ratio of the Rating of statistical capacity (0-100) of Overall level in 2010 to that in 2014?
Your response must be concise. 0.82. What is the ratio of the Rating of statistical capacity (0-100) in Periodicity assessment in 2010 to that in 2014?
Give a very brief answer. 0.97. What is the ratio of the Rating of statistical capacity (0-100) of Source data assessment in 2010 to that in 2014?
Your answer should be very brief. 0.6. What is the ratio of the Rating of statistical capacity (0-100) of Overall level in 2010 to that in 2015?
Give a very brief answer. 0.87. What is the ratio of the Rating of statistical capacity (0-100) in Methodology assessment in 2011 to that in 2012?
Provide a short and direct response. 1. What is the ratio of the Rating of statistical capacity (0-100) in Overall level in 2011 to that in 2012?
Keep it short and to the point. 0.97. What is the ratio of the Rating of statistical capacity (0-100) of Periodicity assessment in 2011 to that in 2012?
Your response must be concise. 0.93. What is the ratio of the Rating of statistical capacity (0-100) of Source data assessment in 2011 to that in 2012?
Offer a terse response. 1. What is the ratio of the Rating of statistical capacity (0-100) of Overall level in 2011 to that in 2013?
Your answer should be very brief. 0.91. What is the ratio of the Rating of statistical capacity (0-100) of Periodicity assessment in 2011 to that in 2013?
Your answer should be very brief. 0.97. What is the ratio of the Rating of statistical capacity (0-100) in Source data assessment in 2011 to that in 2013?
Your answer should be compact. 0.75. What is the ratio of the Rating of statistical capacity (0-100) in Methodology assessment in 2011 to that in 2014?
Ensure brevity in your answer.  0.9. What is the ratio of the Rating of statistical capacity (0-100) of Overall level in 2011 to that in 2014?
Keep it short and to the point. 0.82. What is the ratio of the Rating of statistical capacity (0-100) in Periodicity assessment in 2011 to that in 2014?
Your answer should be very brief. 0.97. What is the ratio of the Rating of statistical capacity (0-100) in Source data assessment in 2011 to that in 2014?
Provide a short and direct response. 0.6. What is the ratio of the Rating of statistical capacity (0-100) in Methodology assessment in 2011 to that in 2015?
Keep it short and to the point. 0.9. What is the ratio of the Rating of statistical capacity (0-100) in Overall level in 2011 to that in 2015?
Provide a short and direct response. 0.87. What is the ratio of the Rating of statistical capacity (0-100) in Periodicity assessment in 2011 to that in 2015?
Make the answer very short. 0.93. What is the ratio of the Rating of statistical capacity (0-100) of Source data assessment in 2011 to that in 2015?
Provide a succinct answer. 0.75. What is the ratio of the Rating of statistical capacity (0-100) in Methodology assessment in 2012 to that in 2013?
Make the answer very short. 1. What is the ratio of the Rating of statistical capacity (0-100) in Overall level in 2012 to that in 2013?
Your answer should be very brief. 0.94. What is the ratio of the Rating of statistical capacity (0-100) of Periodicity assessment in 2012 to that in 2013?
Offer a very short reply. 1.03. What is the ratio of the Rating of statistical capacity (0-100) in Methodology assessment in 2012 to that in 2014?
Provide a short and direct response. 0.9. What is the ratio of the Rating of statistical capacity (0-100) in Overall level in 2012 to that in 2014?
Make the answer very short. 0.84. What is the ratio of the Rating of statistical capacity (0-100) of Periodicity assessment in 2012 to that in 2014?
Your answer should be very brief. 1.03. What is the ratio of the Rating of statistical capacity (0-100) of Source data assessment in 2012 to that in 2014?
Make the answer very short. 0.6. What is the ratio of the Rating of statistical capacity (0-100) of Methodology assessment in 2012 to that in 2015?
Offer a terse response. 0.9. What is the ratio of the Rating of statistical capacity (0-100) in Overall level in 2012 to that in 2015?
Your answer should be very brief. 0.89. What is the ratio of the Rating of statistical capacity (0-100) in Periodicity assessment in 2012 to that in 2015?
Provide a succinct answer. 1. What is the ratio of the Rating of statistical capacity (0-100) of Methodology assessment in 2013 to that in 2014?
Your answer should be very brief. 0.9. What is the ratio of the Rating of statistical capacity (0-100) of Overall level in 2013 to that in 2014?
Make the answer very short. 0.9. What is the ratio of the Rating of statistical capacity (0-100) in Source data assessment in 2013 to that in 2014?
Offer a terse response. 0.8. What is the ratio of the Rating of statistical capacity (0-100) of Methodology assessment in 2013 to that in 2015?
Offer a very short reply. 0.9. What is the ratio of the Rating of statistical capacity (0-100) in Overall level in 2013 to that in 2015?
Your answer should be compact. 0.95. What is the ratio of the Rating of statistical capacity (0-100) of Periodicity assessment in 2013 to that in 2015?
Your response must be concise. 0.97. What is the ratio of the Rating of statistical capacity (0-100) of Methodology assessment in 2014 to that in 2015?
Your answer should be compact. 1. What is the ratio of the Rating of statistical capacity (0-100) of Overall level in 2014 to that in 2015?
Ensure brevity in your answer.  1.06. What is the ratio of the Rating of statistical capacity (0-100) in Periodicity assessment in 2014 to that in 2015?
Your answer should be very brief. 0.97. What is the ratio of the Rating of statistical capacity (0-100) in Source data assessment in 2014 to that in 2015?
Give a very brief answer. 1.25. What is the difference between the highest and the second highest Rating of statistical capacity (0-100) of Methodology assessment?
Your answer should be compact. 0. What is the difference between the highest and the second highest Rating of statistical capacity (0-100) in Overall level?
Make the answer very short. 5.56. What is the difference between the highest and the lowest Rating of statistical capacity (0-100) in Methodology assessment?
Offer a very short reply. 10. What is the difference between the highest and the lowest Rating of statistical capacity (0-100) of Overall level?
Your answer should be very brief. 18.89. What is the difference between the highest and the lowest Rating of statistical capacity (0-100) in Periodicity assessment?
Your answer should be compact. 10. What is the difference between the highest and the lowest Rating of statistical capacity (0-100) of Source data assessment?
Make the answer very short. 40. 